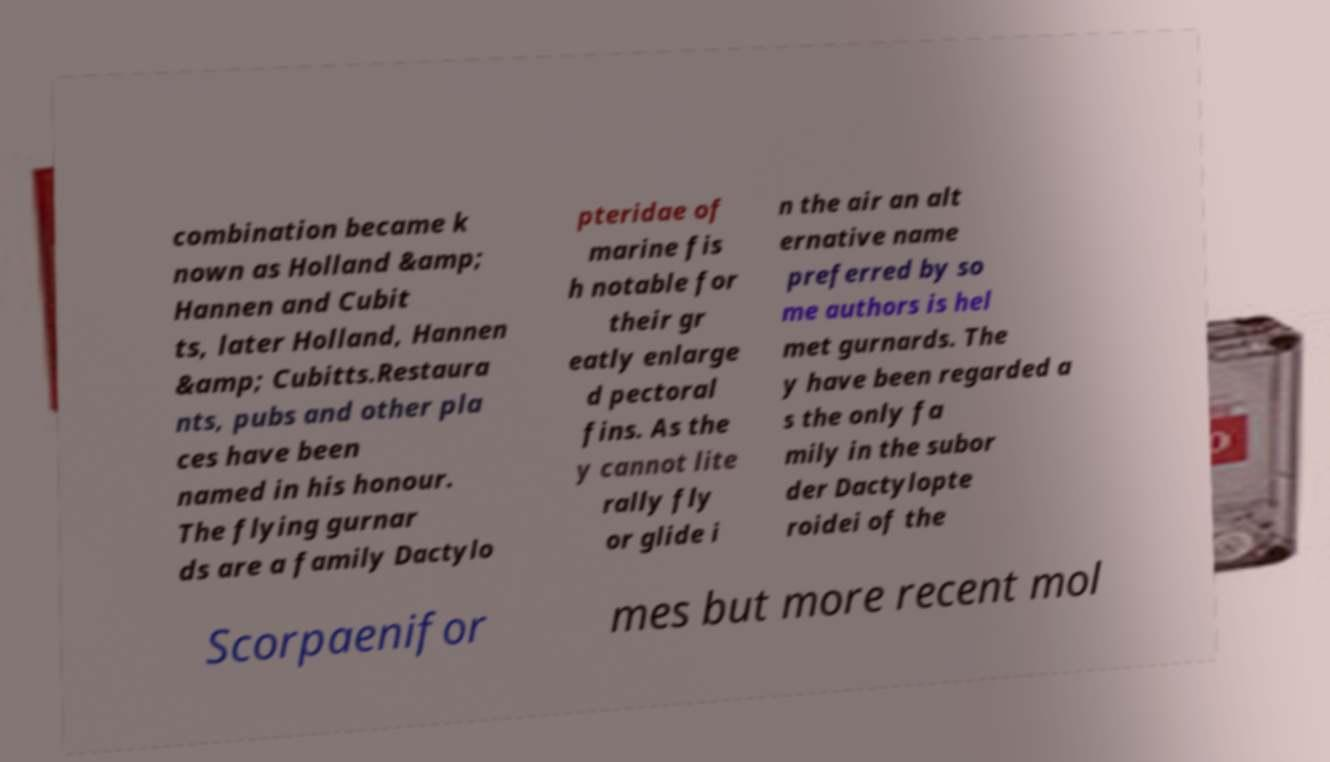I need the written content from this picture converted into text. Can you do that? combination became k nown as Holland &amp; Hannen and Cubit ts, later Holland, Hannen &amp; Cubitts.Restaura nts, pubs and other pla ces have been named in his honour. The flying gurnar ds are a family Dactylo pteridae of marine fis h notable for their gr eatly enlarge d pectoral fins. As the y cannot lite rally fly or glide i n the air an alt ernative name preferred by so me authors is hel met gurnards. The y have been regarded a s the only fa mily in the subor der Dactylopte roidei of the Scorpaenifor mes but more recent mol 